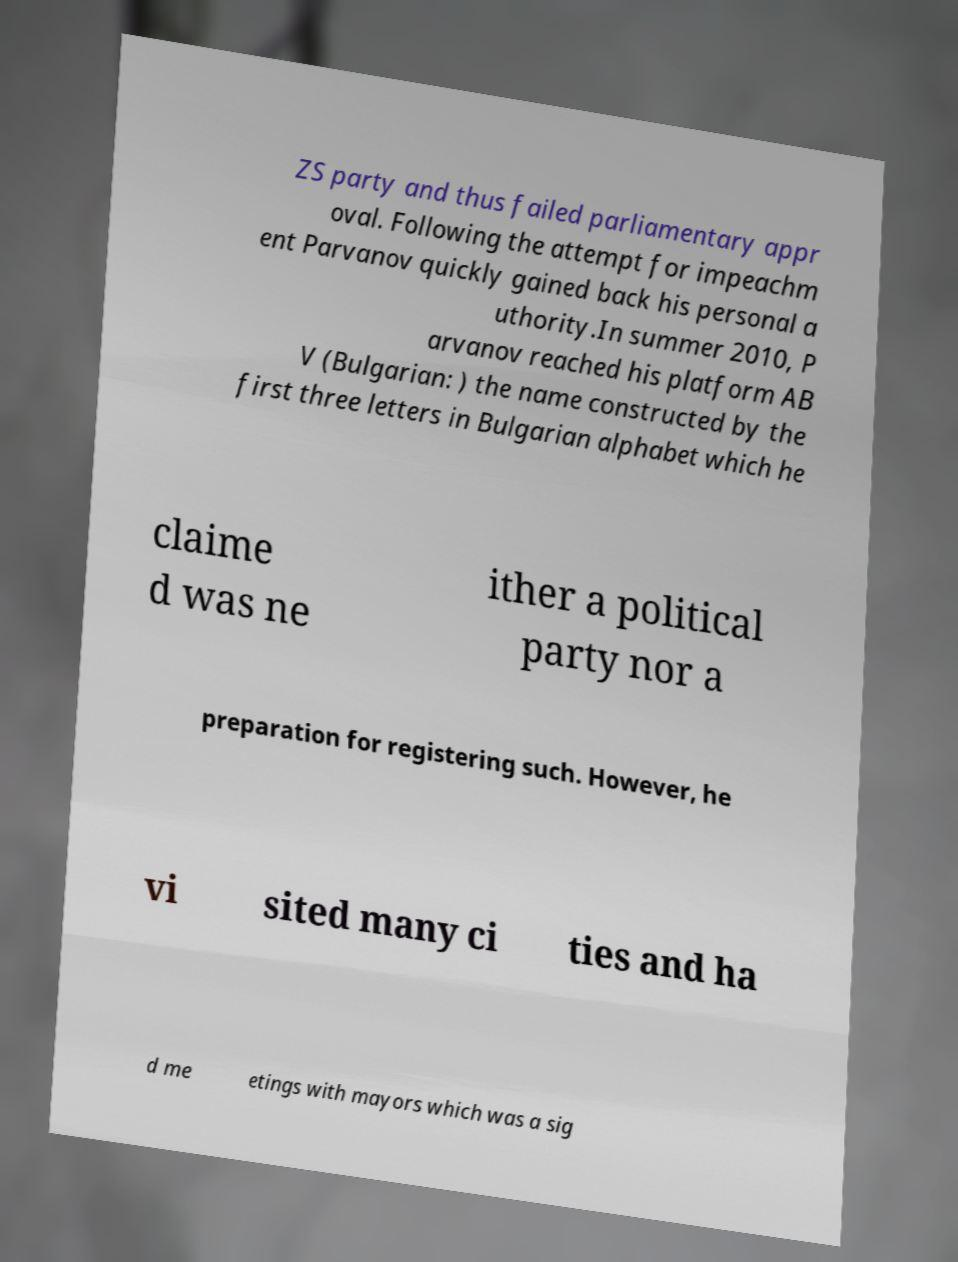I need the written content from this picture converted into text. Can you do that? ZS party and thus failed parliamentary appr oval. Following the attempt for impeachm ent Parvanov quickly gained back his personal a uthority.In summer 2010, P arvanov reached his platform AB V (Bulgarian: ) the name constructed by the first three letters in Bulgarian alphabet which he claime d was ne ither a political party nor a preparation for registering such. However, he vi sited many ci ties and ha d me etings with mayors which was a sig 